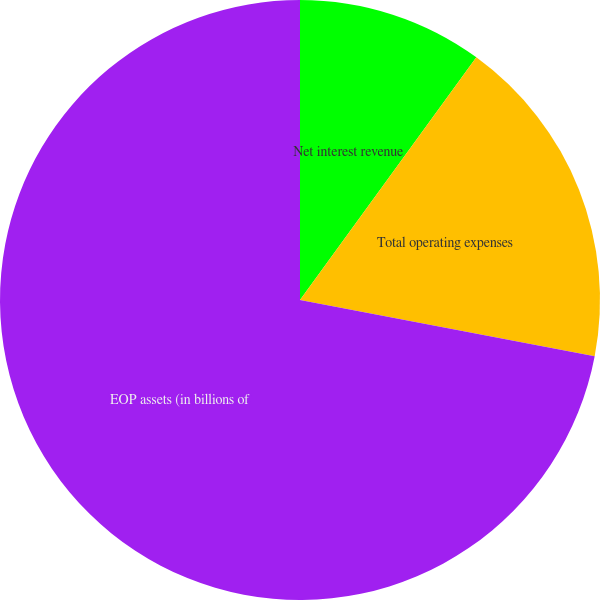Convert chart. <chart><loc_0><loc_0><loc_500><loc_500><pie_chart><fcel>Net interest revenue<fcel>Total operating expenses<fcel>EOP assets (in billions of<nl><fcel>10.0%<fcel>18.0%<fcel>72.0%<nl></chart> 